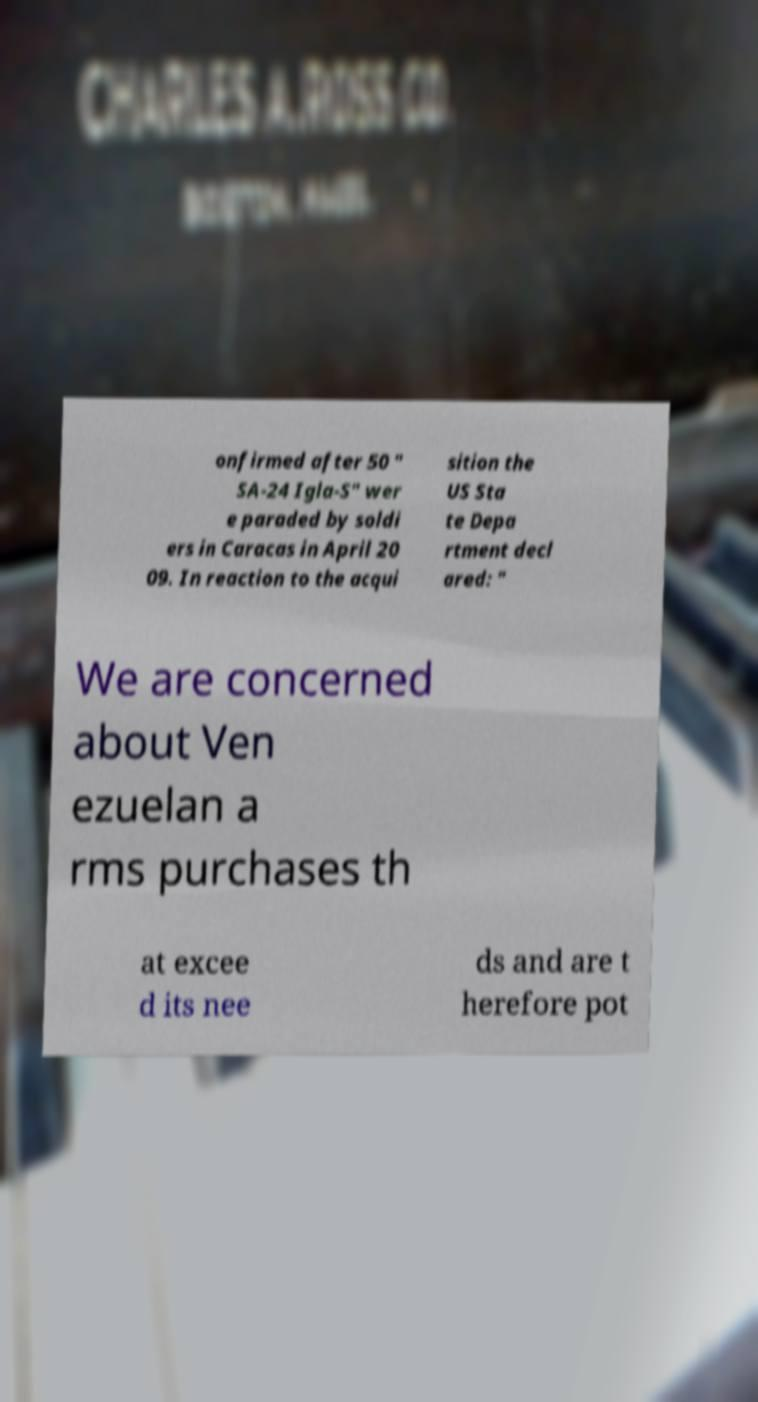Can you accurately transcribe the text from the provided image for me? onfirmed after 50 " SA-24 Igla-S" wer e paraded by soldi ers in Caracas in April 20 09. In reaction to the acqui sition the US Sta te Depa rtment decl ared: " We are concerned about Ven ezuelan a rms purchases th at excee d its nee ds and are t herefore pot 